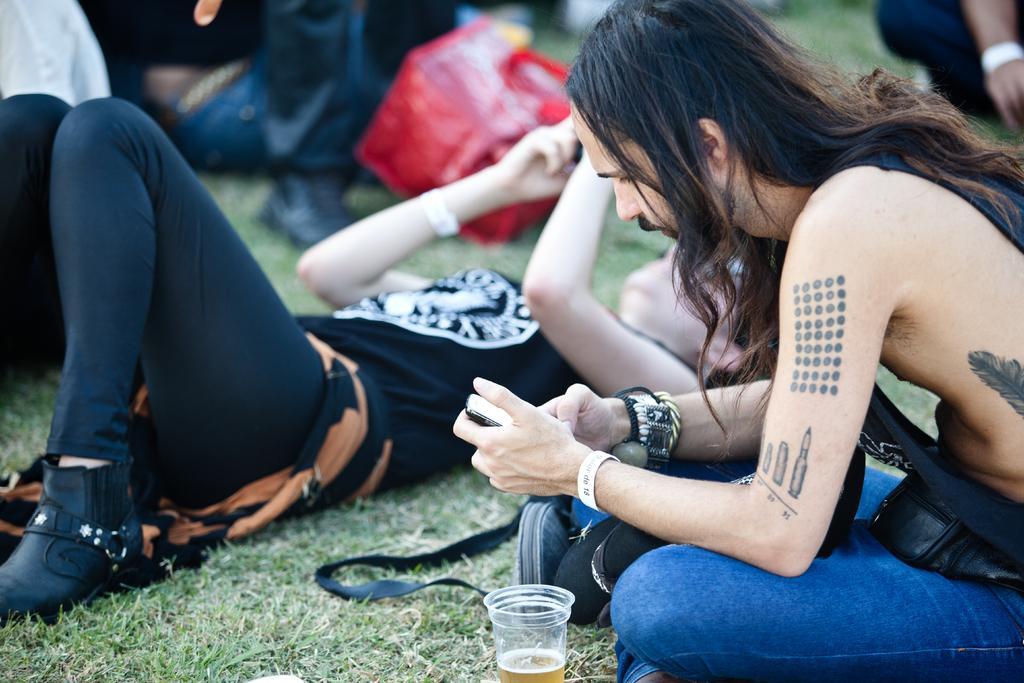Please provide a concise description of this image. In this picture we can see a glass, people sitting and lying on the green grass. They are holding mobiles in their hands. 